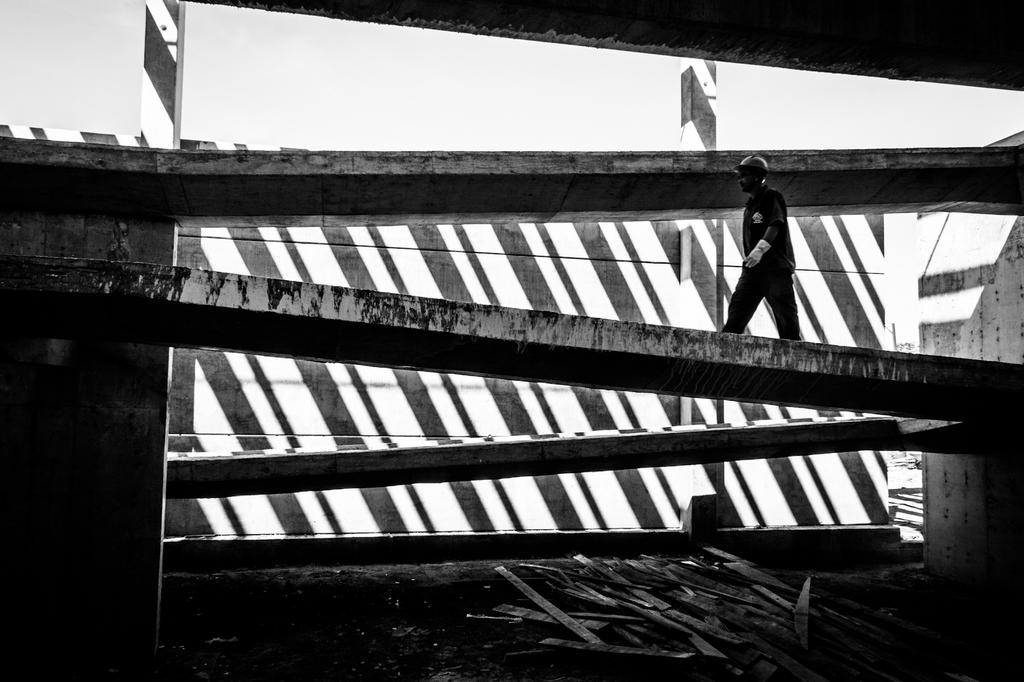Could you give a brief overview of what you see in this image? In this picture we can observe a man wearing a helmet and a white color gloves, walking on this platform. We can observe some wooden sticks on the floor. There is a wall here. In the background there is a sky. 